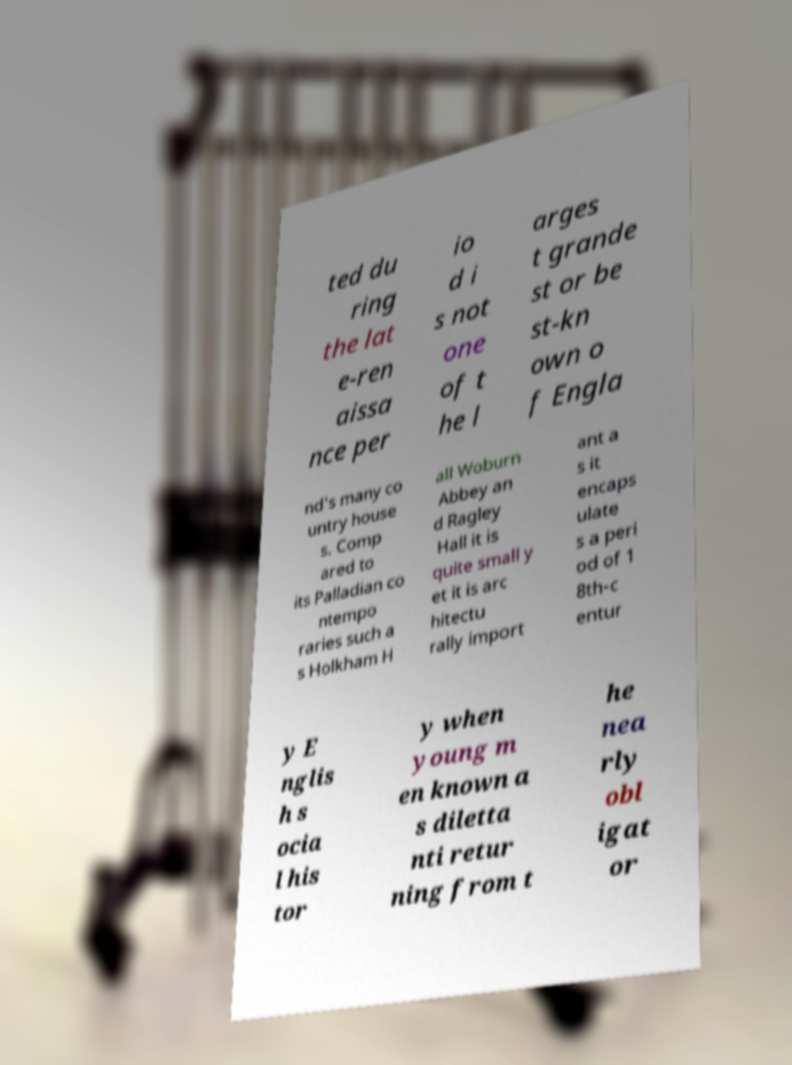Could you assist in decoding the text presented in this image and type it out clearly? ted du ring the lat e-ren aissa nce per io d i s not one of t he l arges t grande st or be st-kn own o f Engla nd's many co untry house s. Comp ared to its Palladian co ntempo raries such a s Holkham H all Woburn Abbey an d Ragley Hall it is quite small y et it is arc hitectu rally import ant a s it encaps ulate s a peri od of 1 8th-c entur y E nglis h s ocia l his tor y when young m en known a s diletta nti retur ning from t he nea rly obl igat or 